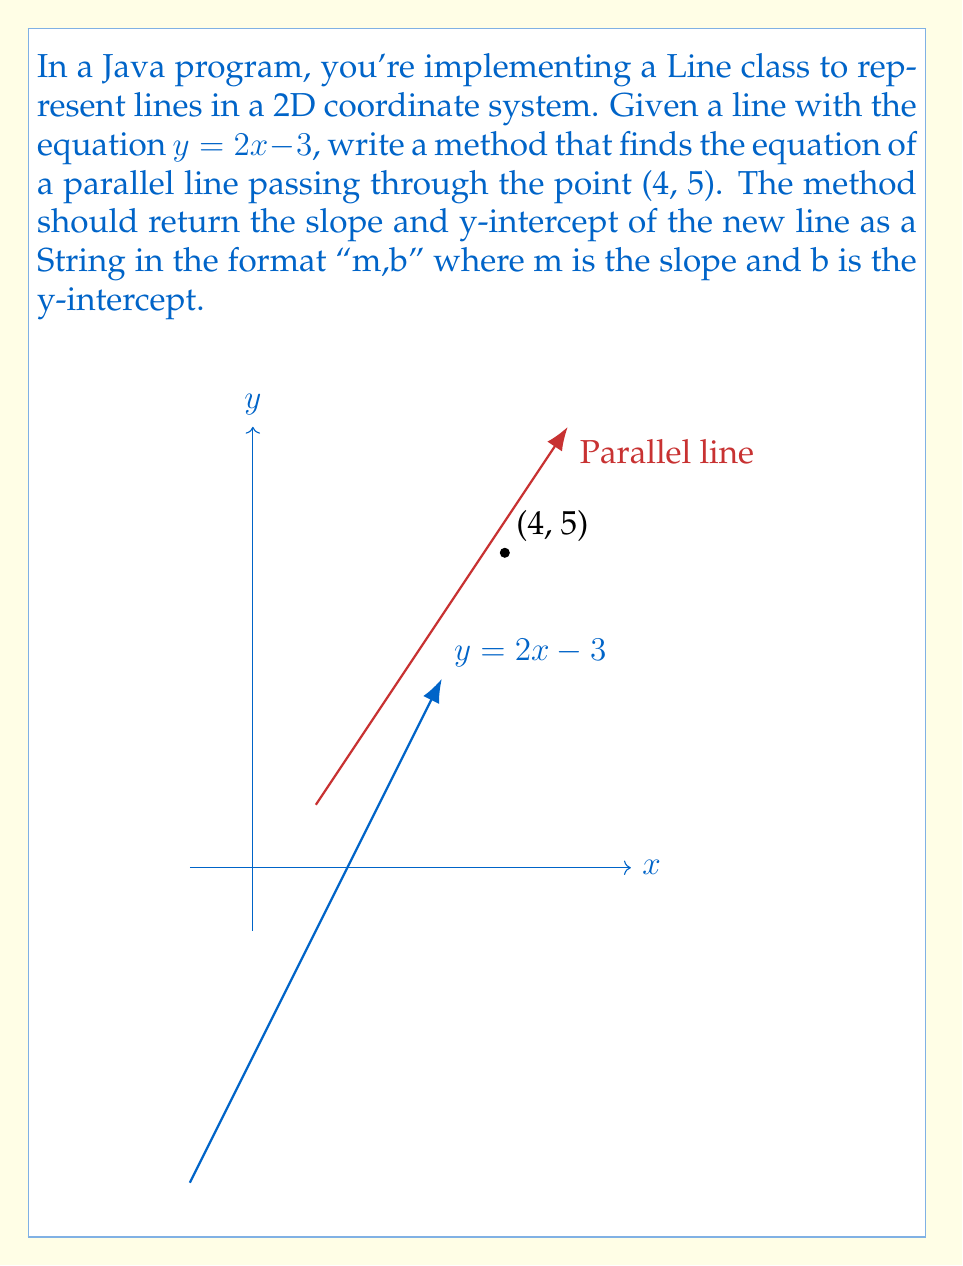Can you solve this math problem? To solve this problem, we'll follow these steps:

1) The slope of the given line $y = 2x - 3$ is 2. Since parallel lines have the same slope, our new line will also have a slope of 2.

2) We can use the point-slope form of a line equation:
   $y - y_1 = m(x - x_1)$
   where $(x_1, y_1)$ is a point on the line and $m$ is the slope.

3) We know the point (4, 5) and the slope 2, so we can plug these into the point-slope form:
   $y - 5 = 2(x - 4)$

4) Expand the right side:
   $y - 5 = 2x - 8$

5) Add 5 to both sides to get y by itself:
   $y = 2x - 8 + 5$
   $y = 2x - 3$

6) Now we have the equation in slope-intercept form: $y = mx + b$
   Where $m = 2$ (slope) and $b = -3$ (y-intercept)

7) In Java, we would return this as a String "2,-3".

This method demonstrates the use of object-oriented principles in Java, where the Line class encapsulates the behavior of finding parallel lines.
Answer: $y = 2x - 3$ 